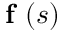Convert formula to latex. <formula><loc_0><loc_0><loc_500><loc_500>f ( s )</formula> 